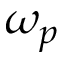Convert formula to latex. <formula><loc_0><loc_0><loc_500><loc_500>\omega _ { p }</formula> 